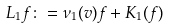Convert formula to latex. <formula><loc_0><loc_0><loc_500><loc_500>L _ { 1 } f \colon = \nu _ { 1 } ( v ) f + K _ { 1 } ( f )</formula> 